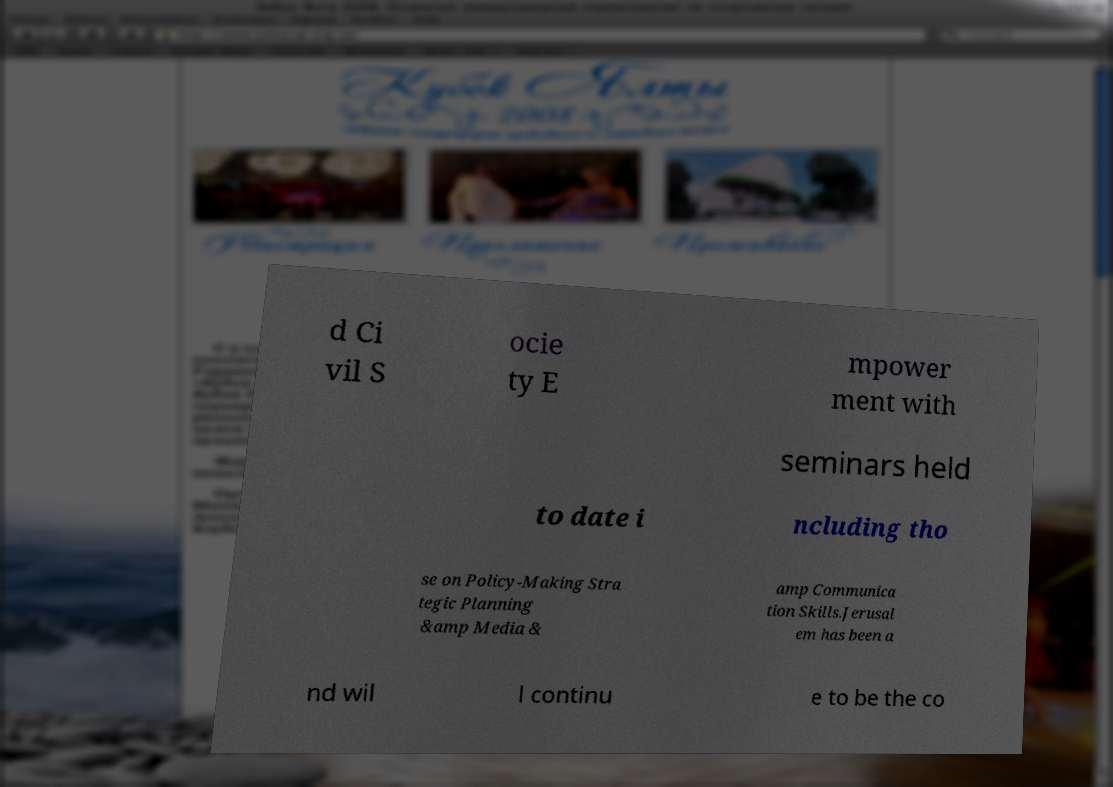Could you assist in decoding the text presented in this image and type it out clearly? d Ci vil S ocie ty E mpower ment with seminars held to date i ncluding tho se on Policy-Making Stra tegic Planning &amp Media & amp Communica tion Skills.Jerusal em has been a nd wil l continu e to be the co 